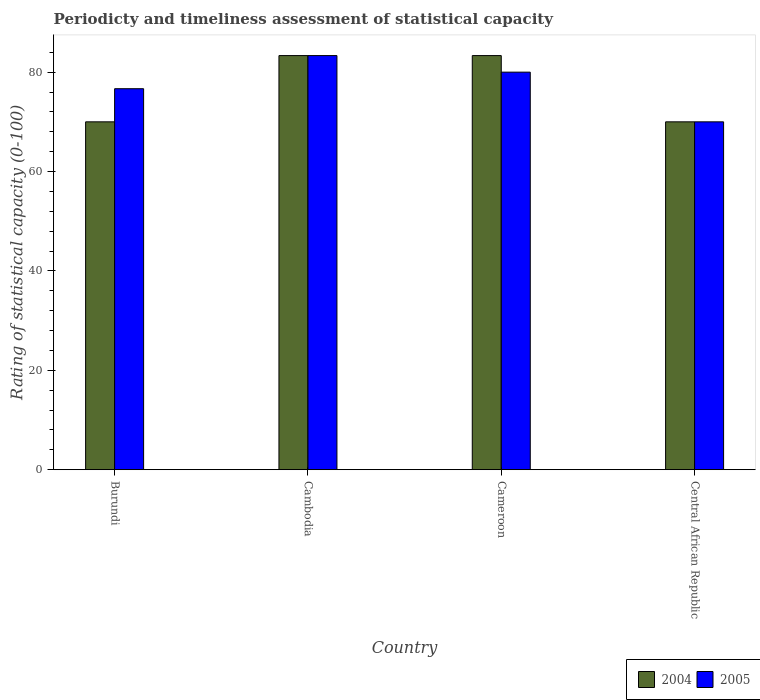How many different coloured bars are there?
Ensure brevity in your answer.  2. How many groups of bars are there?
Your response must be concise. 4. Are the number of bars per tick equal to the number of legend labels?
Provide a succinct answer. Yes. Are the number of bars on each tick of the X-axis equal?
Keep it short and to the point. Yes. How many bars are there on the 3rd tick from the left?
Provide a short and direct response. 2. What is the label of the 2nd group of bars from the left?
Give a very brief answer. Cambodia. What is the rating of statistical capacity in 2004 in Burundi?
Offer a very short reply. 70. Across all countries, what is the maximum rating of statistical capacity in 2004?
Provide a succinct answer. 83.33. Across all countries, what is the minimum rating of statistical capacity in 2004?
Give a very brief answer. 70. In which country was the rating of statistical capacity in 2005 maximum?
Provide a succinct answer. Cambodia. In which country was the rating of statistical capacity in 2005 minimum?
Keep it short and to the point. Central African Republic. What is the total rating of statistical capacity in 2004 in the graph?
Your answer should be very brief. 306.67. What is the difference between the rating of statistical capacity in 2004 in Cameroon and the rating of statistical capacity in 2005 in Burundi?
Your answer should be compact. 6.67. What is the average rating of statistical capacity in 2004 per country?
Ensure brevity in your answer.  76.67. What is the difference between the rating of statistical capacity of/in 2004 and rating of statistical capacity of/in 2005 in Cameroon?
Your answer should be very brief. 3.33. Is the rating of statistical capacity in 2004 in Burundi less than that in Cambodia?
Ensure brevity in your answer.  Yes. Is the difference between the rating of statistical capacity in 2004 in Burundi and Cameroon greater than the difference between the rating of statistical capacity in 2005 in Burundi and Cameroon?
Offer a very short reply. No. What is the difference between the highest and the second highest rating of statistical capacity in 2004?
Keep it short and to the point. 13.33. What is the difference between the highest and the lowest rating of statistical capacity in 2004?
Offer a terse response. 13.33. Are all the bars in the graph horizontal?
Your answer should be very brief. No. How many countries are there in the graph?
Offer a very short reply. 4. Are the values on the major ticks of Y-axis written in scientific E-notation?
Give a very brief answer. No. Does the graph contain grids?
Make the answer very short. No. Where does the legend appear in the graph?
Provide a short and direct response. Bottom right. How are the legend labels stacked?
Keep it short and to the point. Horizontal. What is the title of the graph?
Provide a short and direct response. Periodicty and timeliness assessment of statistical capacity. What is the label or title of the Y-axis?
Provide a succinct answer. Rating of statistical capacity (0-100). What is the Rating of statistical capacity (0-100) of 2005 in Burundi?
Offer a very short reply. 76.67. What is the Rating of statistical capacity (0-100) of 2004 in Cambodia?
Offer a terse response. 83.33. What is the Rating of statistical capacity (0-100) of 2005 in Cambodia?
Provide a succinct answer. 83.33. What is the Rating of statistical capacity (0-100) in 2004 in Cameroon?
Offer a very short reply. 83.33. What is the Rating of statistical capacity (0-100) in 2005 in Cameroon?
Provide a succinct answer. 80. What is the Rating of statistical capacity (0-100) of 2004 in Central African Republic?
Offer a terse response. 70. What is the Rating of statistical capacity (0-100) in 2005 in Central African Republic?
Your answer should be compact. 70. Across all countries, what is the maximum Rating of statistical capacity (0-100) in 2004?
Make the answer very short. 83.33. Across all countries, what is the maximum Rating of statistical capacity (0-100) of 2005?
Make the answer very short. 83.33. Across all countries, what is the minimum Rating of statistical capacity (0-100) in 2004?
Your answer should be compact. 70. What is the total Rating of statistical capacity (0-100) in 2004 in the graph?
Give a very brief answer. 306.67. What is the total Rating of statistical capacity (0-100) of 2005 in the graph?
Your response must be concise. 310. What is the difference between the Rating of statistical capacity (0-100) of 2004 in Burundi and that in Cambodia?
Your answer should be very brief. -13.33. What is the difference between the Rating of statistical capacity (0-100) in 2005 in Burundi and that in Cambodia?
Offer a very short reply. -6.67. What is the difference between the Rating of statistical capacity (0-100) in 2004 in Burundi and that in Cameroon?
Your answer should be very brief. -13.33. What is the difference between the Rating of statistical capacity (0-100) in 2004 in Burundi and that in Central African Republic?
Your answer should be compact. 0. What is the difference between the Rating of statistical capacity (0-100) in 2005 in Burundi and that in Central African Republic?
Keep it short and to the point. 6.67. What is the difference between the Rating of statistical capacity (0-100) of 2004 in Cambodia and that in Central African Republic?
Provide a succinct answer. 13.33. What is the difference between the Rating of statistical capacity (0-100) of 2005 in Cambodia and that in Central African Republic?
Keep it short and to the point. 13.33. What is the difference between the Rating of statistical capacity (0-100) in 2004 in Cameroon and that in Central African Republic?
Your answer should be compact. 13.33. What is the difference between the Rating of statistical capacity (0-100) of 2004 in Burundi and the Rating of statistical capacity (0-100) of 2005 in Cambodia?
Keep it short and to the point. -13.33. What is the difference between the Rating of statistical capacity (0-100) of 2004 in Burundi and the Rating of statistical capacity (0-100) of 2005 in Central African Republic?
Provide a succinct answer. 0. What is the difference between the Rating of statistical capacity (0-100) in 2004 in Cambodia and the Rating of statistical capacity (0-100) in 2005 in Central African Republic?
Your response must be concise. 13.33. What is the difference between the Rating of statistical capacity (0-100) in 2004 in Cameroon and the Rating of statistical capacity (0-100) in 2005 in Central African Republic?
Your answer should be compact. 13.33. What is the average Rating of statistical capacity (0-100) of 2004 per country?
Ensure brevity in your answer.  76.67. What is the average Rating of statistical capacity (0-100) in 2005 per country?
Your answer should be compact. 77.5. What is the difference between the Rating of statistical capacity (0-100) of 2004 and Rating of statistical capacity (0-100) of 2005 in Burundi?
Your answer should be compact. -6.67. What is the difference between the Rating of statistical capacity (0-100) of 2004 and Rating of statistical capacity (0-100) of 2005 in Cameroon?
Provide a short and direct response. 3.33. What is the ratio of the Rating of statistical capacity (0-100) of 2004 in Burundi to that in Cambodia?
Make the answer very short. 0.84. What is the ratio of the Rating of statistical capacity (0-100) in 2004 in Burundi to that in Cameroon?
Ensure brevity in your answer.  0.84. What is the ratio of the Rating of statistical capacity (0-100) in 2005 in Burundi to that in Cameroon?
Offer a very short reply. 0.96. What is the ratio of the Rating of statistical capacity (0-100) of 2005 in Burundi to that in Central African Republic?
Offer a very short reply. 1.1. What is the ratio of the Rating of statistical capacity (0-100) in 2004 in Cambodia to that in Cameroon?
Offer a very short reply. 1. What is the ratio of the Rating of statistical capacity (0-100) in 2005 in Cambodia to that in Cameroon?
Provide a short and direct response. 1.04. What is the ratio of the Rating of statistical capacity (0-100) of 2004 in Cambodia to that in Central African Republic?
Your answer should be very brief. 1.19. What is the ratio of the Rating of statistical capacity (0-100) in 2005 in Cambodia to that in Central African Republic?
Ensure brevity in your answer.  1.19. What is the ratio of the Rating of statistical capacity (0-100) in 2004 in Cameroon to that in Central African Republic?
Your answer should be very brief. 1.19. What is the difference between the highest and the second highest Rating of statistical capacity (0-100) of 2005?
Offer a terse response. 3.33. What is the difference between the highest and the lowest Rating of statistical capacity (0-100) of 2004?
Your answer should be compact. 13.33. What is the difference between the highest and the lowest Rating of statistical capacity (0-100) in 2005?
Offer a very short reply. 13.33. 